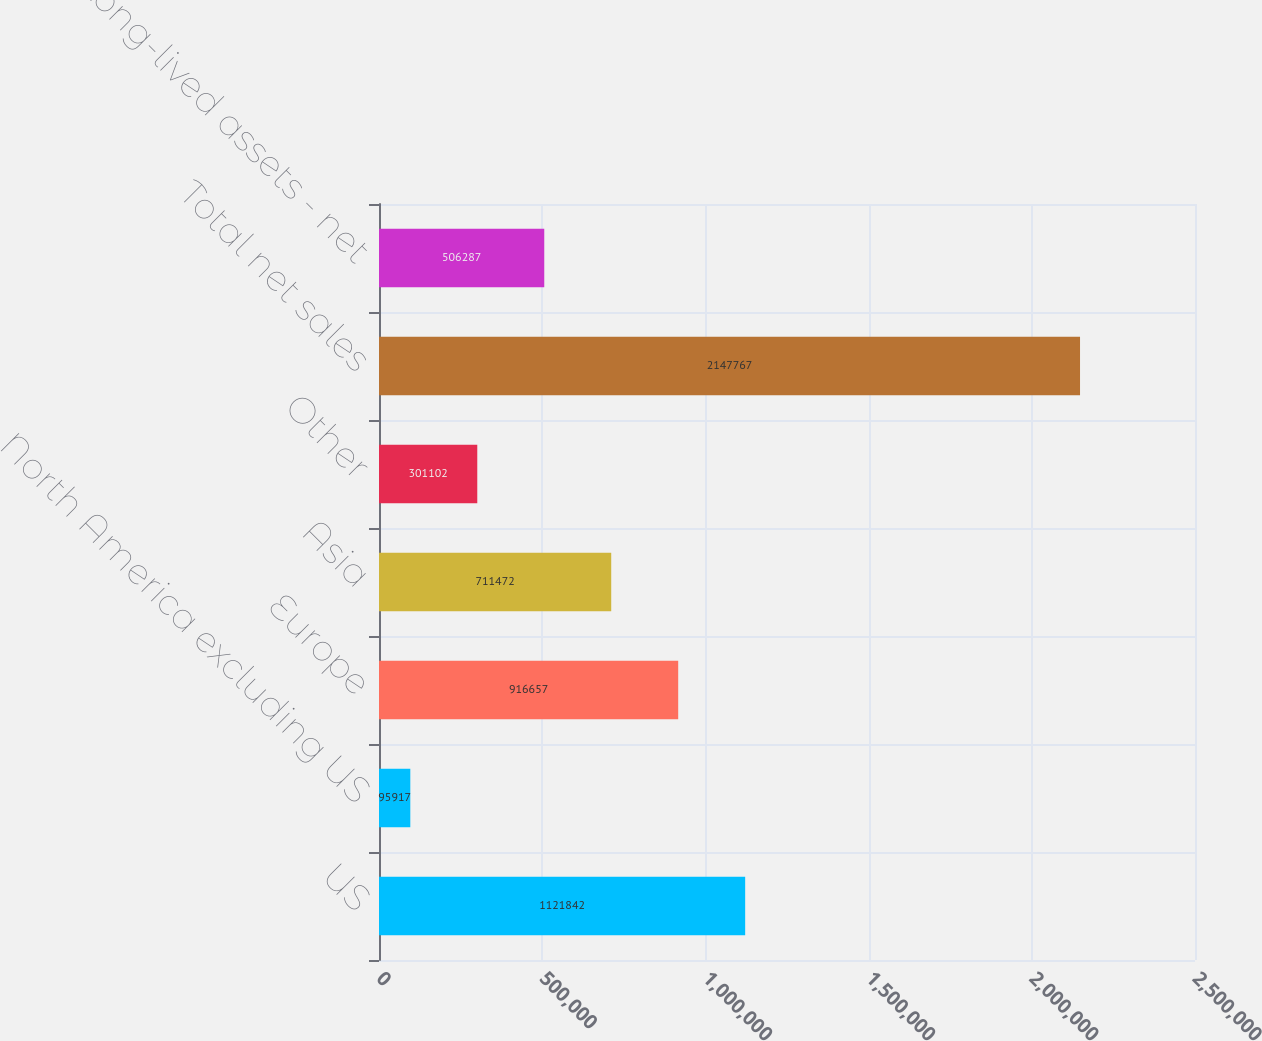<chart> <loc_0><loc_0><loc_500><loc_500><bar_chart><fcel>US<fcel>North America excluding US<fcel>Europe<fcel>Asia<fcel>Other<fcel>Total net sales<fcel>Total long-lived assets - net<nl><fcel>1.12184e+06<fcel>95917<fcel>916657<fcel>711472<fcel>301102<fcel>2.14777e+06<fcel>506287<nl></chart> 